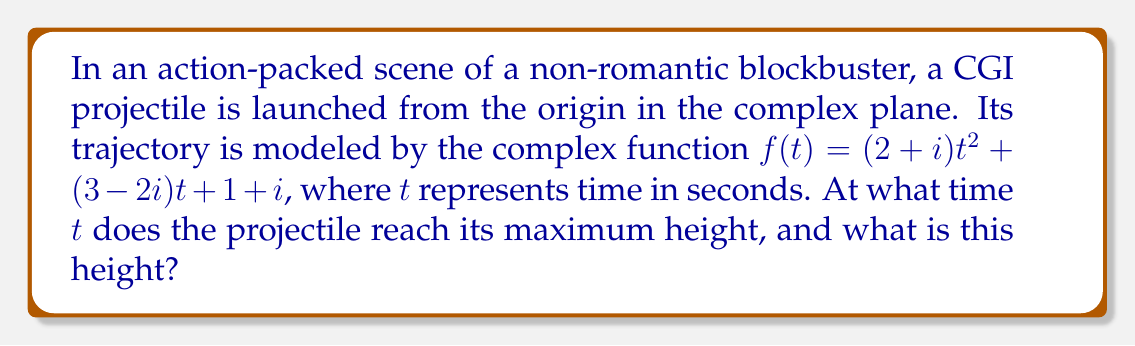Help me with this question. To solve this problem, we need to follow these steps:

1) The trajectory is given by $f(t) = (2+i)t^2 + (3-2i)t + 1+i$. The imaginary part of this function represents the height of the projectile.

2) Let's separate the real and imaginary parts:
   $f(t) = (2t^2 + 3t + 1) + i(t^2 - 2t + 1)$

3) The height function is the imaginary part: $h(t) = t^2 - 2t + 1$

4) To find the maximum height, we need to find where the derivative of $h(t)$ is zero:
   $h'(t) = 2t - 2$

5) Set $h'(t) = 0$:
   $2t - 2 = 0$
   $2t = 2$
   $t = 1$

6) To confirm this is a maximum (not a minimum), we can check the second derivative:
   $h''(t) = 2 > 0$, so this is indeed a maximum.

7) The time at which the maximum height occurs is $t = 1$ second.

8) To find the maximum height, we substitute $t = 1$ into $h(t)$:
   $h(1) = 1^2 - 2(1) + 1 = 0$

Therefore, the projectile reaches its maximum height of 0 units at $t = 1$ second.
Answer: The projectile reaches its maximum height at $t = 1$ second, and the maximum height is 0 units. 